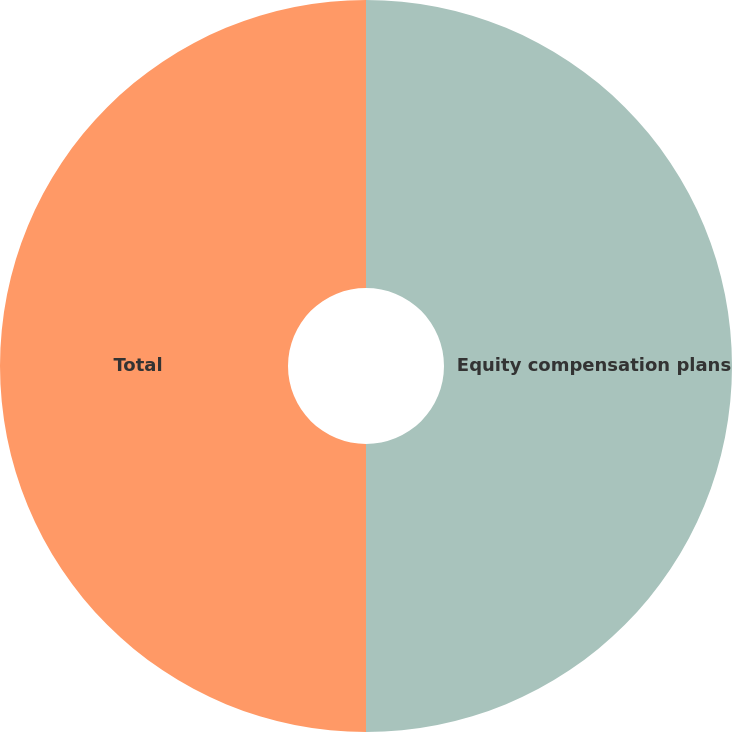<chart> <loc_0><loc_0><loc_500><loc_500><pie_chart><fcel>Equity compensation plans<fcel>Total<nl><fcel>50.0%<fcel>50.0%<nl></chart> 